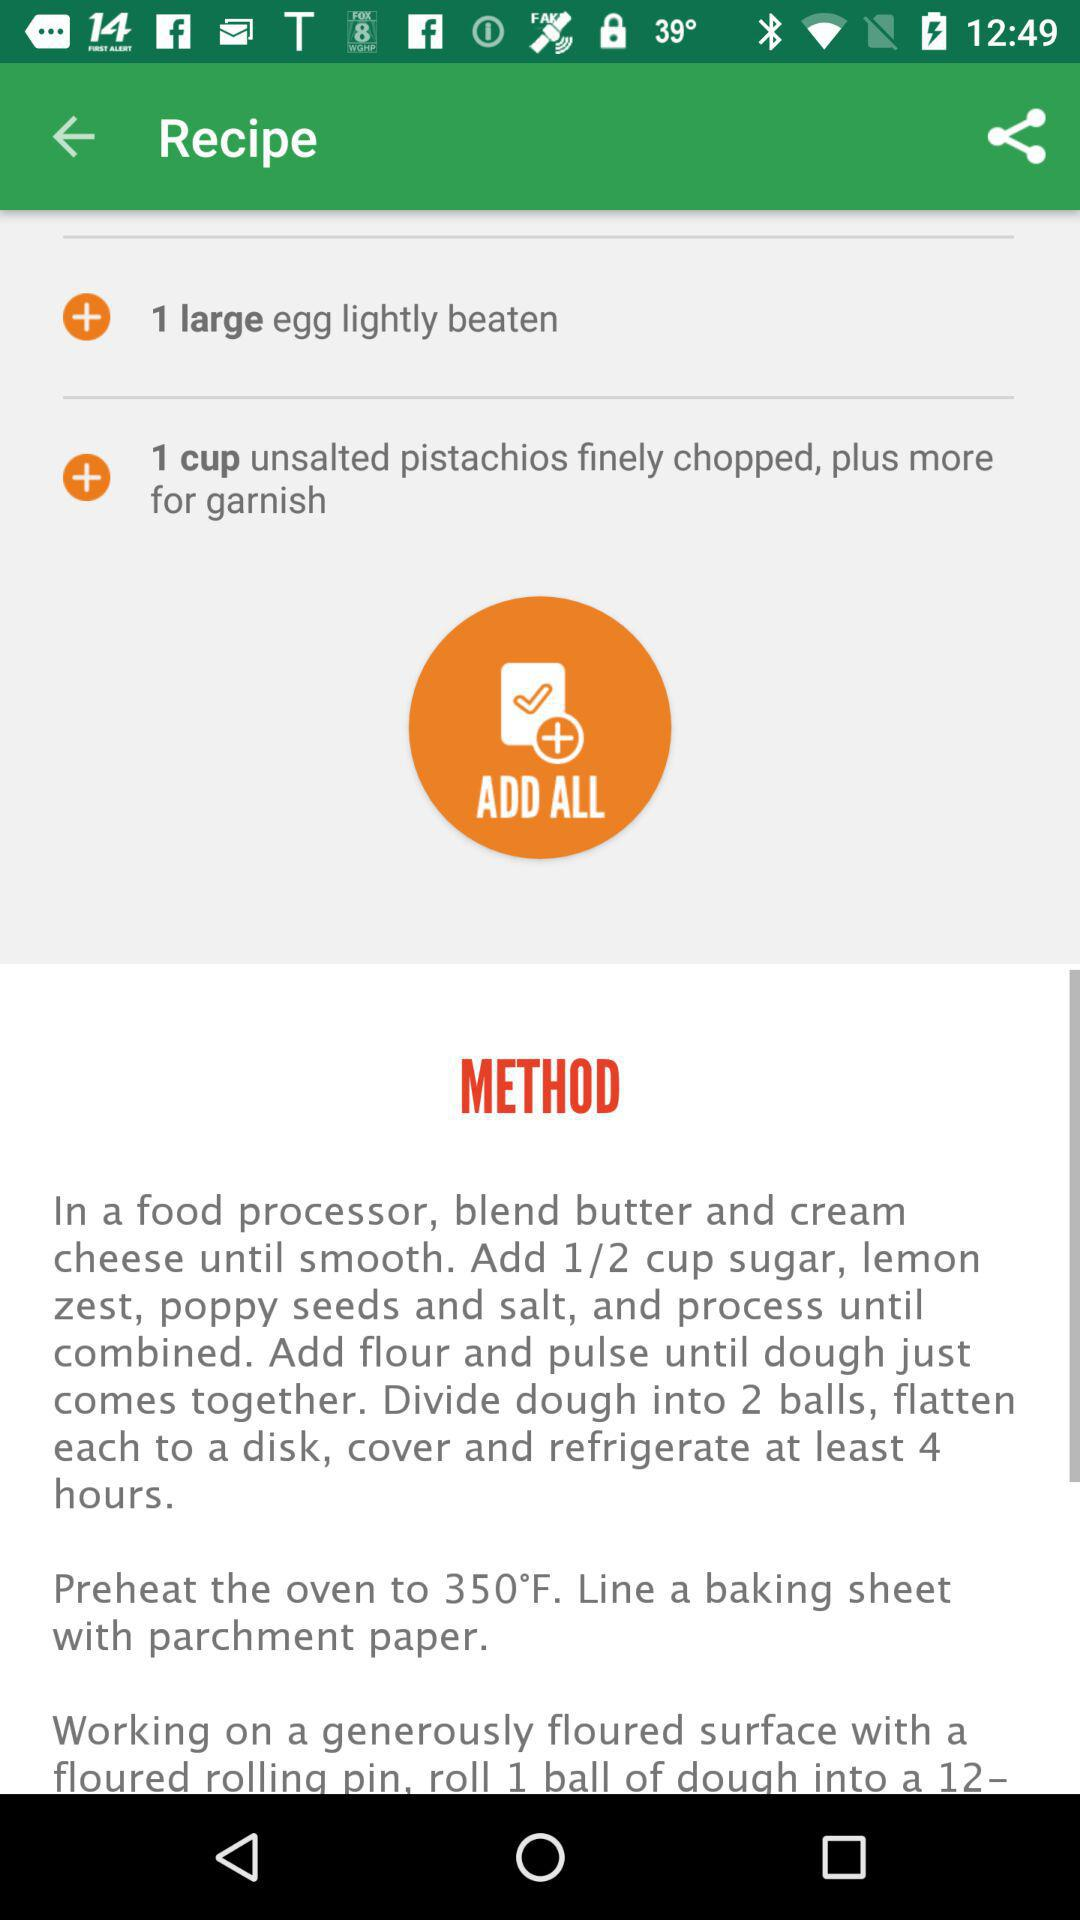How many lightly beaten eggs are required? There is 1 large, lightly beaten egg required. 